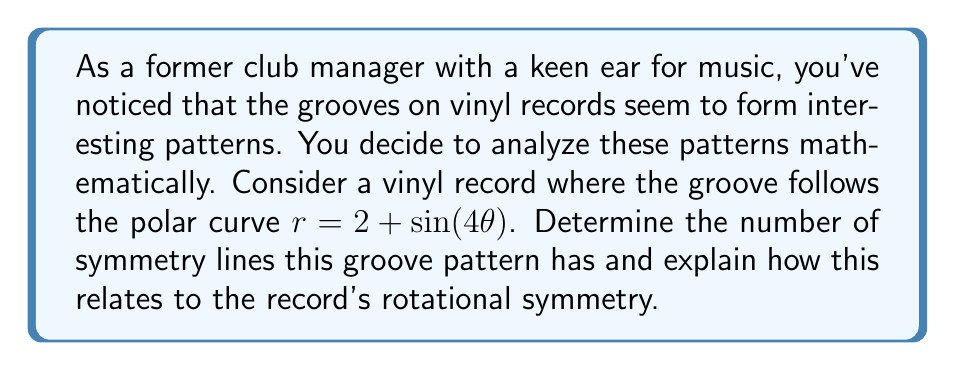Provide a solution to this math problem. To analyze the symmetry of the vinyl record's grooves, we need to examine the polar curve $r = 2 + \sin(4\theta)$. Let's break this down step-by-step:

1) First, recall that a polar curve has n-fold rotational symmetry if it repeats itself every $\frac{2\pi}{n}$ radians.

2) In this case, we need to find the smallest positive value of $\alpha$ such that:

   $2 + \sin(4\theta) = 2 + \sin(4(\theta + \alpha))$

3) This equality holds when:

   $\sin(4\theta) = \sin(4\theta + 4\alpha)$

4) This is true when $4\alpha$ is a multiple of $2\pi$, or when $\alpha$ is a multiple of $\frac{\pi}{2}$.

5) The smallest positive value of $\alpha$ that satisfies this is $\frac{\pi}{2}$.

6) This means the curve repeats itself every $\frac{\pi}{2}$ radians, or 4 times in a full $2\pi$ rotation.

7) Therefore, the curve has 4-fold rotational symmetry.

8) In terms of symmetry lines, a curve with n-fold rotational symmetry has n symmetry lines.

9) These symmetry lines occur at angles of $\frac{k\pi}{n}$ for $k = 0, 1, ..., n-1$.

10) In this case, the symmetry lines occur at angles of $0$, $\frac{\pi}{4}$, $\frac{\pi}{2}$, and $\frac{3\pi}{4}$.

[asy]
import graph;
size(200);
real r(real t) {return 2+sin(4t);}
path g=polargraph(r,0,2pi);
draw(g,red);
draw((-2.5,0)--(2.5,0),blue);
draw((0,-2.5)--(0,2.5),blue);
draw((-1.77,1.77)--(1.77,-1.77),blue);
draw((-1.77,-1.77)--(1.77,1.77),blue);
[/asy]

This 4-fold symmetry means that the groove pattern on the vinyl record would repeat itself 4 times in one complete rotation, creating a visually interesting and balanced design that a discerning club manager might appreciate.
Answer: The groove pattern has 4 symmetry lines, occurring at angles of $0$, $\frac{\pi}{4}$, $\frac{\pi}{2}$, and $\frac{3\pi}{4}$. This corresponds to 4-fold rotational symmetry. 